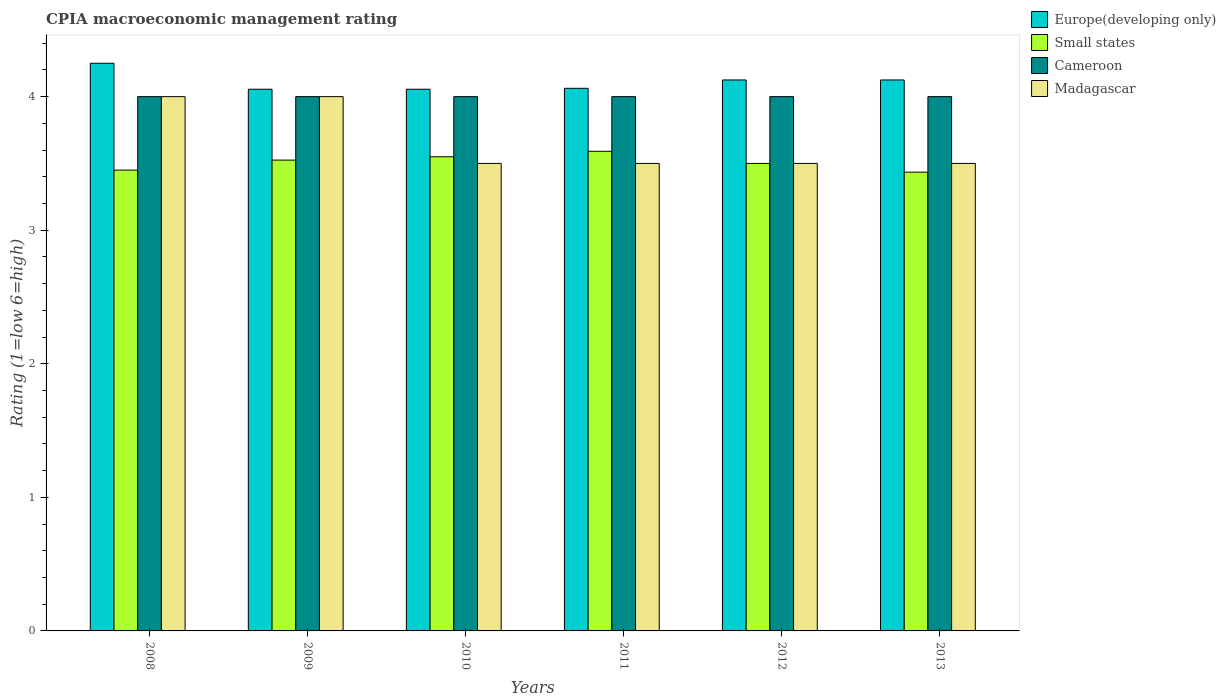How many groups of bars are there?
Ensure brevity in your answer.  6. How many bars are there on the 4th tick from the left?
Give a very brief answer. 4. How many bars are there on the 5th tick from the right?
Your response must be concise. 4. What is the label of the 3rd group of bars from the left?
Ensure brevity in your answer.  2010. In how many cases, is the number of bars for a given year not equal to the number of legend labels?
Your response must be concise. 0. What is the CPIA rating in Europe(developing only) in 2010?
Ensure brevity in your answer.  4.06. Across all years, what is the maximum CPIA rating in Cameroon?
Your answer should be very brief. 4. Across all years, what is the minimum CPIA rating in Madagascar?
Keep it short and to the point. 3.5. In which year was the CPIA rating in Small states maximum?
Your answer should be compact. 2011. What is the total CPIA rating in Cameroon in the graph?
Provide a succinct answer. 24. What is the difference between the CPIA rating in Small states in 2010 and that in 2012?
Offer a very short reply. 0.05. What is the difference between the CPIA rating in Madagascar in 2010 and the CPIA rating in Small states in 2012?
Your response must be concise. 0. What is the average CPIA rating in Europe(developing only) per year?
Offer a very short reply. 4.11. In the year 2013, what is the difference between the CPIA rating in Small states and CPIA rating in Europe(developing only)?
Offer a very short reply. -0.69. What is the ratio of the CPIA rating in Cameroon in 2009 to that in 2010?
Give a very brief answer. 1. Is the difference between the CPIA rating in Small states in 2011 and 2013 greater than the difference between the CPIA rating in Europe(developing only) in 2011 and 2013?
Offer a terse response. Yes. What is the difference between the highest and the second highest CPIA rating in Madagascar?
Provide a short and direct response. 0. What is the difference between the highest and the lowest CPIA rating in Cameroon?
Your response must be concise. 0. What does the 2nd bar from the left in 2009 represents?
Your answer should be very brief. Small states. What does the 4th bar from the right in 2010 represents?
Your answer should be compact. Europe(developing only). Is it the case that in every year, the sum of the CPIA rating in Cameroon and CPIA rating in Europe(developing only) is greater than the CPIA rating in Madagascar?
Provide a succinct answer. Yes. How many bars are there?
Provide a succinct answer. 24. Are the values on the major ticks of Y-axis written in scientific E-notation?
Keep it short and to the point. No. Does the graph contain any zero values?
Your answer should be compact. No. How many legend labels are there?
Provide a succinct answer. 4. How are the legend labels stacked?
Ensure brevity in your answer.  Vertical. What is the title of the graph?
Offer a very short reply. CPIA macroeconomic management rating. What is the label or title of the Y-axis?
Give a very brief answer. Rating (1=low 6=high). What is the Rating (1=low 6=high) in Europe(developing only) in 2008?
Ensure brevity in your answer.  4.25. What is the Rating (1=low 6=high) of Small states in 2008?
Ensure brevity in your answer.  3.45. What is the Rating (1=low 6=high) of Madagascar in 2008?
Keep it short and to the point. 4. What is the Rating (1=low 6=high) in Europe(developing only) in 2009?
Keep it short and to the point. 4.06. What is the Rating (1=low 6=high) of Small states in 2009?
Offer a terse response. 3.52. What is the Rating (1=low 6=high) in Europe(developing only) in 2010?
Your answer should be very brief. 4.06. What is the Rating (1=low 6=high) of Small states in 2010?
Your answer should be very brief. 3.55. What is the Rating (1=low 6=high) of Cameroon in 2010?
Provide a succinct answer. 4. What is the Rating (1=low 6=high) of Europe(developing only) in 2011?
Give a very brief answer. 4.06. What is the Rating (1=low 6=high) in Small states in 2011?
Provide a succinct answer. 3.59. What is the Rating (1=low 6=high) of Europe(developing only) in 2012?
Provide a short and direct response. 4.12. What is the Rating (1=low 6=high) in Small states in 2012?
Your answer should be very brief. 3.5. What is the Rating (1=low 6=high) of Madagascar in 2012?
Offer a terse response. 3.5. What is the Rating (1=low 6=high) of Europe(developing only) in 2013?
Offer a very short reply. 4.12. What is the Rating (1=low 6=high) of Small states in 2013?
Provide a succinct answer. 3.43. What is the Rating (1=low 6=high) in Cameroon in 2013?
Your response must be concise. 4. What is the Rating (1=low 6=high) of Madagascar in 2013?
Make the answer very short. 3.5. Across all years, what is the maximum Rating (1=low 6=high) in Europe(developing only)?
Make the answer very short. 4.25. Across all years, what is the maximum Rating (1=low 6=high) of Small states?
Provide a short and direct response. 3.59. Across all years, what is the maximum Rating (1=low 6=high) of Madagascar?
Offer a terse response. 4. Across all years, what is the minimum Rating (1=low 6=high) in Europe(developing only)?
Provide a short and direct response. 4.06. Across all years, what is the minimum Rating (1=low 6=high) of Small states?
Give a very brief answer. 3.43. What is the total Rating (1=low 6=high) in Europe(developing only) in the graph?
Provide a succinct answer. 24.67. What is the total Rating (1=low 6=high) of Small states in the graph?
Make the answer very short. 21.05. What is the total Rating (1=low 6=high) of Cameroon in the graph?
Offer a terse response. 24. What is the difference between the Rating (1=low 6=high) in Europe(developing only) in 2008 and that in 2009?
Give a very brief answer. 0.19. What is the difference between the Rating (1=low 6=high) in Small states in 2008 and that in 2009?
Offer a very short reply. -0.07. What is the difference between the Rating (1=low 6=high) of Madagascar in 2008 and that in 2009?
Your answer should be compact. 0. What is the difference between the Rating (1=low 6=high) of Europe(developing only) in 2008 and that in 2010?
Offer a terse response. 0.19. What is the difference between the Rating (1=low 6=high) of Cameroon in 2008 and that in 2010?
Your answer should be compact. 0. What is the difference between the Rating (1=low 6=high) of Madagascar in 2008 and that in 2010?
Provide a short and direct response. 0.5. What is the difference between the Rating (1=low 6=high) of Europe(developing only) in 2008 and that in 2011?
Your answer should be compact. 0.19. What is the difference between the Rating (1=low 6=high) in Small states in 2008 and that in 2011?
Keep it short and to the point. -0.14. What is the difference between the Rating (1=low 6=high) in Cameroon in 2008 and that in 2011?
Offer a very short reply. 0. What is the difference between the Rating (1=low 6=high) of Madagascar in 2008 and that in 2011?
Keep it short and to the point. 0.5. What is the difference between the Rating (1=low 6=high) in Cameroon in 2008 and that in 2012?
Your answer should be compact. 0. What is the difference between the Rating (1=low 6=high) in Madagascar in 2008 and that in 2012?
Give a very brief answer. 0.5. What is the difference between the Rating (1=low 6=high) in Europe(developing only) in 2008 and that in 2013?
Provide a short and direct response. 0.12. What is the difference between the Rating (1=low 6=high) in Small states in 2008 and that in 2013?
Ensure brevity in your answer.  0.02. What is the difference between the Rating (1=low 6=high) in Cameroon in 2008 and that in 2013?
Offer a very short reply. 0. What is the difference between the Rating (1=low 6=high) of Europe(developing only) in 2009 and that in 2010?
Give a very brief answer. 0. What is the difference between the Rating (1=low 6=high) of Small states in 2009 and that in 2010?
Offer a terse response. -0.03. What is the difference between the Rating (1=low 6=high) of Cameroon in 2009 and that in 2010?
Give a very brief answer. 0. What is the difference between the Rating (1=low 6=high) in Europe(developing only) in 2009 and that in 2011?
Offer a terse response. -0.01. What is the difference between the Rating (1=low 6=high) of Small states in 2009 and that in 2011?
Provide a short and direct response. -0.07. What is the difference between the Rating (1=low 6=high) of Madagascar in 2009 and that in 2011?
Provide a short and direct response. 0.5. What is the difference between the Rating (1=low 6=high) of Europe(developing only) in 2009 and that in 2012?
Provide a short and direct response. -0.07. What is the difference between the Rating (1=low 6=high) of Small states in 2009 and that in 2012?
Ensure brevity in your answer.  0.03. What is the difference between the Rating (1=low 6=high) of Cameroon in 2009 and that in 2012?
Keep it short and to the point. 0. What is the difference between the Rating (1=low 6=high) of Madagascar in 2009 and that in 2012?
Provide a succinct answer. 0.5. What is the difference between the Rating (1=low 6=high) in Europe(developing only) in 2009 and that in 2013?
Provide a succinct answer. -0.07. What is the difference between the Rating (1=low 6=high) in Small states in 2009 and that in 2013?
Keep it short and to the point. 0.09. What is the difference between the Rating (1=low 6=high) in Cameroon in 2009 and that in 2013?
Your answer should be very brief. 0. What is the difference between the Rating (1=low 6=high) of Europe(developing only) in 2010 and that in 2011?
Provide a short and direct response. -0.01. What is the difference between the Rating (1=low 6=high) in Small states in 2010 and that in 2011?
Provide a short and direct response. -0.04. What is the difference between the Rating (1=low 6=high) in Cameroon in 2010 and that in 2011?
Offer a very short reply. 0. What is the difference between the Rating (1=low 6=high) of Europe(developing only) in 2010 and that in 2012?
Provide a short and direct response. -0.07. What is the difference between the Rating (1=low 6=high) of Small states in 2010 and that in 2012?
Your answer should be compact. 0.05. What is the difference between the Rating (1=low 6=high) of Cameroon in 2010 and that in 2012?
Provide a succinct answer. 0. What is the difference between the Rating (1=low 6=high) of Europe(developing only) in 2010 and that in 2013?
Offer a terse response. -0.07. What is the difference between the Rating (1=low 6=high) of Small states in 2010 and that in 2013?
Keep it short and to the point. 0.12. What is the difference between the Rating (1=low 6=high) in Madagascar in 2010 and that in 2013?
Your answer should be compact. 0. What is the difference between the Rating (1=low 6=high) of Europe(developing only) in 2011 and that in 2012?
Your response must be concise. -0.06. What is the difference between the Rating (1=low 6=high) in Small states in 2011 and that in 2012?
Keep it short and to the point. 0.09. What is the difference between the Rating (1=low 6=high) of Cameroon in 2011 and that in 2012?
Make the answer very short. 0. What is the difference between the Rating (1=low 6=high) in Madagascar in 2011 and that in 2012?
Offer a very short reply. 0. What is the difference between the Rating (1=low 6=high) of Europe(developing only) in 2011 and that in 2013?
Offer a terse response. -0.06. What is the difference between the Rating (1=low 6=high) in Small states in 2011 and that in 2013?
Your answer should be very brief. 0.16. What is the difference between the Rating (1=low 6=high) in Cameroon in 2011 and that in 2013?
Your response must be concise. 0. What is the difference between the Rating (1=low 6=high) of Europe(developing only) in 2012 and that in 2013?
Offer a terse response. 0. What is the difference between the Rating (1=low 6=high) in Small states in 2012 and that in 2013?
Make the answer very short. 0.07. What is the difference between the Rating (1=low 6=high) in Cameroon in 2012 and that in 2013?
Your answer should be compact. 0. What is the difference between the Rating (1=low 6=high) in Europe(developing only) in 2008 and the Rating (1=low 6=high) in Small states in 2009?
Provide a succinct answer. 0.72. What is the difference between the Rating (1=low 6=high) in Europe(developing only) in 2008 and the Rating (1=low 6=high) in Cameroon in 2009?
Your answer should be compact. 0.25. What is the difference between the Rating (1=low 6=high) in Small states in 2008 and the Rating (1=low 6=high) in Cameroon in 2009?
Provide a succinct answer. -0.55. What is the difference between the Rating (1=low 6=high) of Small states in 2008 and the Rating (1=low 6=high) of Madagascar in 2009?
Your answer should be very brief. -0.55. What is the difference between the Rating (1=low 6=high) in Europe(developing only) in 2008 and the Rating (1=low 6=high) in Small states in 2010?
Give a very brief answer. 0.7. What is the difference between the Rating (1=low 6=high) of Small states in 2008 and the Rating (1=low 6=high) of Cameroon in 2010?
Offer a very short reply. -0.55. What is the difference between the Rating (1=low 6=high) in Small states in 2008 and the Rating (1=low 6=high) in Madagascar in 2010?
Ensure brevity in your answer.  -0.05. What is the difference between the Rating (1=low 6=high) in Cameroon in 2008 and the Rating (1=low 6=high) in Madagascar in 2010?
Provide a short and direct response. 0.5. What is the difference between the Rating (1=low 6=high) in Europe(developing only) in 2008 and the Rating (1=low 6=high) in Small states in 2011?
Provide a succinct answer. 0.66. What is the difference between the Rating (1=low 6=high) in Europe(developing only) in 2008 and the Rating (1=low 6=high) in Madagascar in 2011?
Keep it short and to the point. 0.75. What is the difference between the Rating (1=low 6=high) of Small states in 2008 and the Rating (1=low 6=high) of Cameroon in 2011?
Your response must be concise. -0.55. What is the difference between the Rating (1=low 6=high) of Europe(developing only) in 2008 and the Rating (1=low 6=high) of Small states in 2012?
Provide a short and direct response. 0.75. What is the difference between the Rating (1=low 6=high) of Europe(developing only) in 2008 and the Rating (1=low 6=high) of Madagascar in 2012?
Provide a succinct answer. 0.75. What is the difference between the Rating (1=low 6=high) in Small states in 2008 and the Rating (1=low 6=high) in Cameroon in 2012?
Keep it short and to the point. -0.55. What is the difference between the Rating (1=low 6=high) in Small states in 2008 and the Rating (1=low 6=high) in Madagascar in 2012?
Provide a succinct answer. -0.05. What is the difference between the Rating (1=low 6=high) of Cameroon in 2008 and the Rating (1=low 6=high) of Madagascar in 2012?
Give a very brief answer. 0.5. What is the difference between the Rating (1=low 6=high) in Europe(developing only) in 2008 and the Rating (1=low 6=high) in Small states in 2013?
Your response must be concise. 0.82. What is the difference between the Rating (1=low 6=high) of Europe(developing only) in 2008 and the Rating (1=low 6=high) of Cameroon in 2013?
Offer a terse response. 0.25. What is the difference between the Rating (1=low 6=high) in Europe(developing only) in 2008 and the Rating (1=low 6=high) in Madagascar in 2013?
Your response must be concise. 0.75. What is the difference between the Rating (1=low 6=high) in Small states in 2008 and the Rating (1=low 6=high) in Cameroon in 2013?
Ensure brevity in your answer.  -0.55. What is the difference between the Rating (1=low 6=high) of Small states in 2008 and the Rating (1=low 6=high) of Madagascar in 2013?
Keep it short and to the point. -0.05. What is the difference between the Rating (1=low 6=high) of Europe(developing only) in 2009 and the Rating (1=low 6=high) of Small states in 2010?
Provide a short and direct response. 0.51. What is the difference between the Rating (1=low 6=high) in Europe(developing only) in 2009 and the Rating (1=low 6=high) in Cameroon in 2010?
Provide a short and direct response. 0.06. What is the difference between the Rating (1=low 6=high) in Europe(developing only) in 2009 and the Rating (1=low 6=high) in Madagascar in 2010?
Your answer should be very brief. 0.56. What is the difference between the Rating (1=low 6=high) of Small states in 2009 and the Rating (1=low 6=high) of Cameroon in 2010?
Keep it short and to the point. -0.47. What is the difference between the Rating (1=low 6=high) of Small states in 2009 and the Rating (1=low 6=high) of Madagascar in 2010?
Your answer should be very brief. 0.03. What is the difference between the Rating (1=low 6=high) in Europe(developing only) in 2009 and the Rating (1=low 6=high) in Small states in 2011?
Give a very brief answer. 0.46. What is the difference between the Rating (1=low 6=high) in Europe(developing only) in 2009 and the Rating (1=low 6=high) in Cameroon in 2011?
Provide a succinct answer. 0.06. What is the difference between the Rating (1=low 6=high) in Europe(developing only) in 2009 and the Rating (1=low 6=high) in Madagascar in 2011?
Offer a very short reply. 0.56. What is the difference between the Rating (1=low 6=high) in Small states in 2009 and the Rating (1=low 6=high) in Cameroon in 2011?
Your response must be concise. -0.47. What is the difference between the Rating (1=low 6=high) of Small states in 2009 and the Rating (1=low 6=high) of Madagascar in 2011?
Give a very brief answer. 0.03. What is the difference between the Rating (1=low 6=high) of Cameroon in 2009 and the Rating (1=low 6=high) of Madagascar in 2011?
Keep it short and to the point. 0.5. What is the difference between the Rating (1=low 6=high) of Europe(developing only) in 2009 and the Rating (1=low 6=high) of Small states in 2012?
Your answer should be compact. 0.56. What is the difference between the Rating (1=low 6=high) of Europe(developing only) in 2009 and the Rating (1=low 6=high) of Cameroon in 2012?
Provide a succinct answer. 0.06. What is the difference between the Rating (1=low 6=high) of Europe(developing only) in 2009 and the Rating (1=low 6=high) of Madagascar in 2012?
Offer a very short reply. 0.56. What is the difference between the Rating (1=low 6=high) of Small states in 2009 and the Rating (1=low 6=high) of Cameroon in 2012?
Your response must be concise. -0.47. What is the difference between the Rating (1=low 6=high) of Small states in 2009 and the Rating (1=low 6=high) of Madagascar in 2012?
Your answer should be compact. 0.03. What is the difference between the Rating (1=low 6=high) of Europe(developing only) in 2009 and the Rating (1=low 6=high) of Small states in 2013?
Offer a terse response. 0.62. What is the difference between the Rating (1=low 6=high) in Europe(developing only) in 2009 and the Rating (1=low 6=high) in Cameroon in 2013?
Your answer should be very brief. 0.06. What is the difference between the Rating (1=low 6=high) in Europe(developing only) in 2009 and the Rating (1=low 6=high) in Madagascar in 2013?
Offer a very short reply. 0.56. What is the difference between the Rating (1=low 6=high) of Small states in 2009 and the Rating (1=low 6=high) of Cameroon in 2013?
Your response must be concise. -0.47. What is the difference between the Rating (1=low 6=high) in Small states in 2009 and the Rating (1=low 6=high) in Madagascar in 2013?
Ensure brevity in your answer.  0.03. What is the difference between the Rating (1=low 6=high) in Cameroon in 2009 and the Rating (1=low 6=high) in Madagascar in 2013?
Give a very brief answer. 0.5. What is the difference between the Rating (1=low 6=high) of Europe(developing only) in 2010 and the Rating (1=low 6=high) of Small states in 2011?
Your answer should be compact. 0.46. What is the difference between the Rating (1=low 6=high) of Europe(developing only) in 2010 and the Rating (1=low 6=high) of Cameroon in 2011?
Give a very brief answer. 0.06. What is the difference between the Rating (1=low 6=high) in Europe(developing only) in 2010 and the Rating (1=low 6=high) in Madagascar in 2011?
Offer a terse response. 0.56. What is the difference between the Rating (1=low 6=high) in Small states in 2010 and the Rating (1=low 6=high) in Cameroon in 2011?
Offer a terse response. -0.45. What is the difference between the Rating (1=low 6=high) of Small states in 2010 and the Rating (1=low 6=high) of Madagascar in 2011?
Give a very brief answer. 0.05. What is the difference between the Rating (1=low 6=high) of Cameroon in 2010 and the Rating (1=low 6=high) of Madagascar in 2011?
Offer a very short reply. 0.5. What is the difference between the Rating (1=low 6=high) in Europe(developing only) in 2010 and the Rating (1=low 6=high) in Small states in 2012?
Your response must be concise. 0.56. What is the difference between the Rating (1=low 6=high) of Europe(developing only) in 2010 and the Rating (1=low 6=high) of Cameroon in 2012?
Ensure brevity in your answer.  0.06. What is the difference between the Rating (1=low 6=high) of Europe(developing only) in 2010 and the Rating (1=low 6=high) of Madagascar in 2012?
Your answer should be very brief. 0.56. What is the difference between the Rating (1=low 6=high) in Small states in 2010 and the Rating (1=low 6=high) in Cameroon in 2012?
Keep it short and to the point. -0.45. What is the difference between the Rating (1=low 6=high) in Small states in 2010 and the Rating (1=low 6=high) in Madagascar in 2012?
Your answer should be very brief. 0.05. What is the difference between the Rating (1=low 6=high) of Europe(developing only) in 2010 and the Rating (1=low 6=high) of Small states in 2013?
Your answer should be compact. 0.62. What is the difference between the Rating (1=low 6=high) in Europe(developing only) in 2010 and the Rating (1=low 6=high) in Cameroon in 2013?
Offer a terse response. 0.06. What is the difference between the Rating (1=low 6=high) in Europe(developing only) in 2010 and the Rating (1=low 6=high) in Madagascar in 2013?
Your response must be concise. 0.56. What is the difference between the Rating (1=low 6=high) in Small states in 2010 and the Rating (1=low 6=high) in Cameroon in 2013?
Offer a terse response. -0.45. What is the difference between the Rating (1=low 6=high) in Europe(developing only) in 2011 and the Rating (1=low 6=high) in Small states in 2012?
Give a very brief answer. 0.56. What is the difference between the Rating (1=low 6=high) in Europe(developing only) in 2011 and the Rating (1=low 6=high) in Cameroon in 2012?
Offer a very short reply. 0.06. What is the difference between the Rating (1=low 6=high) in Europe(developing only) in 2011 and the Rating (1=low 6=high) in Madagascar in 2012?
Make the answer very short. 0.56. What is the difference between the Rating (1=low 6=high) of Small states in 2011 and the Rating (1=low 6=high) of Cameroon in 2012?
Provide a succinct answer. -0.41. What is the difference between the Rating (1=low 6=high) in Small states in 2011 and the Rating (1=low 6=high) in Madagascar in 2012?
Provide a succinct answer. 0.09. What is the difference between the Rating (1=low 6=high) of Cameroon in 2011 and the Rating (1=low 6=high) of Madagascar in 2012?
Provide a succinct answer. 0.5. What is the difference between the Rating (1=low 6=high) in Europe(developing only) in 2011 and the Rating (1=low 6=high) in Small states in 2013?
Keep it short and to the point. 0.63. What is the difference between the Rating (1=low 6=high) in Europe(developing only) in 2011 and the Rating (1=low 6=high) in Cameroon in 2013?
Make the answer very short. 0.06. What is the difference between the Rating (1=low 6=high) of Europe(developing only) in 2011 and the Rating (1=low 6=high) of Madagascar in 2013?
Ensure brevity in your answer.  0.56. What is the difference between the Rating (1=low 6=high) of Small states in 2011 and the Rating (1=low 6=high) of Cameroon in 2013?
Provide a succinct answer. -0.41. What is the difference between the Rating (1=low 6=high) in Small states in 2011 and the Rating (1=low 6=high) in Madagascar in 2013?
Give a very brief answer. 0.09. What is the difference between the Rating (1=low 6=high) of Europe(developing only) in 2012 and the Rating (1=low 6=high) of Small states in 2013?
Your answer should be very brief. 0.69. What is the difference between the Rating (1=low 6=high) of Europe(developing only) in 2012 and the Rating (1=low 6=high) of Madagascar in 2013?
Ensure brevity in your answer.  0.62. What is the difference between the Rating (1=low 6=high) in Small states in 2012 and the Rating (1=low 6=high) in Cameroon in 2013?
Your response must be concise. -0.5. What is the average Rating (1=low 6=high) of Europe(developing only) per year?
Keep it short and to the point. 4.11. What is the average Rating (1=low 6=high) in Small states per year?
Make the answer very short. 3.51. What is the average Rating (1=low 6=high) in Madagascar per year?
Keep it short and to the point. 3.67. In the year 2008, what is the difference between the Rating (1=low 6=high) in Europe(developing only) and Rating (1=low 6=high) in Cameroon?
Ensure brevity in your answer.  0.25. In the year 2008, what is the difference between the Rating (1=low 6=high) in Europe(developing only) and Rating (1=low 6=high) in Madagascar?
Make the answer very short. 0.25. In the year 2008, what is the difference between the Rating (1=low 6=high) in Small states and Rating (1=low 6=high) in Cameroon?
Offer a terse response. -0.55. In the year 2008, what is the difference between the Rating (1=low 6=high) of Small states and Rating (1=low 6=high) of Madagascar?
Your answer should be very brief. -0.55. In the year 2008, what is the difference between the Rating (1=low 6=high) in Cameroon and Rating (1=low 6=high) in Madagascar?
Offer a terse response. 0. In the year 2009, what is the difference between the Rating (1=low 6=high) in Europe(developing only) and Rating (1=low 6=high) in Small states?
Your response must be concise. 0.53. In the year 2009, what is the difference between the Rating (1=low 6=high) of Europe(developing only) and Rating (1=low 6=high) of Cameroon?
Provide a short and direct response. 0.06. In the year 2009, what is the difference between the Rating (1=low 6=high) in Europe(developing only) and Rating (1=low 6=high) in Madagascar?
Provide a succinct answer. 0.06. In the year 2009, what is the difference between the Rating (1=low 6=high) of Small states and Rating (1=low 6=high) of Cameroon?
Give a very brief answer. -0.47. In the year 2009, what is the difference between the Rating (1=low 6=high) in Small states and Rating (1=low 6=high) in Madagascar?
Your response must be concise. -0.47. In the year 2009, what is the difference between the Rating (1=low 6=high) in Cameroon and Rating (1=low 6=high) in Madagascar?
Give a very brief answer. 0. In the year 2010, what is the difference between the Rating (1=low 6=high) of Europe(developing only) and Rating (1=low 6=high) of Small states?
Ensure brevity in your answer.  0.51. In the year 2010, what is the difference between the Rating (1=low 6=high) of Europe(developing only) and Rating (1=low 6=high) of Cameroon?
Offer a very short reply. 0.06. In the year 2010, what is the difference between the Rating (1=low 6=high) of Europe(developing only) and Rating (1=low 6=high) of Madagascar?
Provide a short and direct response. 0.56. In the year 2010, what is the difference between the Rating (1=low 6=high) in Small states and Rating (1=low 6=high) in Cameroon?
Offer a very short reply. -0.45. In the year 2010, what is the difference between the Rating (1=low 6=high) in Small states and Rating (1=low 6=high) in Madagascar?
Offer a terse response. 0.05. In the year 2011, what is the difference between the Rating (1=low 6=high) in Europe(developing only) and Rating (1=low 6=high) in Small states?
Keep it short and to the point. 0.47. In the year 2011, what is the difference between the Rating (1=low 6=high) in Europe(developing only) and Rating (1=low 6=high) in Cameroon?
Ensure brevity in your answer.  0.06. In the year 2011, what is the difference between the Rating (1=low 6=high) of Europe(developing only) and Rating (1=low 6=high) of Madagascar?
Provide a succinct answer. 0.56. In the year 2011, what is the difference between the Rating (1=low 6=high) of Small states and Rating (1=low 6=high) of Cameroon?
Your answer should be compact. -0.41. In the year 2011, what is the difference between the Rating (1=low 6=high) in Small states and Rating (1=low 6=high) in Madagascar?
Provide a short and direct response. 0.09. In the year 2012, what is the difference between the Rating (1=low 6=high) of Europe(developing only) and Rating (1=low 6=high) of Small states?
Ensure brevity in your answer.  0.62. In the year 2012, what is the difference between the Rating (1=low 6=high) of Europe(developing only) and Rating (1=low 6=high) of Cameroon?
Ensure brevity in your answer.  0.12. In the year 2012, what is the difference between the Rating (1=low 6=high) in Europe(developing only) and Rating (1=low 6=high) in Madagascar?
Offer a terse response. 0.62. In the year 2012, what is the difference between the Rating (1=low 6=high) in Small states and Rating (1=low 6=high) in Cameroon?
Make the answer very short. -0.5. In the year 2013, what is the difference between the Rating (1=low 6=high) in Europe(developing only) and Rating (1=low 6=high) in Small states?
Provide a succinct answer. 0.69. In the year 2013, what is the difference between the Rating (1=low 6=high) of Europe(developing only) and Rating (1=low 6=high) of Cameroon?
Provide a succinct answer. 0.12. In the year 2013, what is the difference between the Rating (1=low 6=high) of Europe(developing only) and Rating (1=low 6=high) of Madagascar?
Your answer should be compact. 0.62. In the year 2013, what is the difference between the Rating (1=low 6=high) of Small states and Rating (1=low 6=high) of Cameroon?
Offer a terse response. -0.57. In the year 2013, what is the difference between the Rating (1=low 6=high) of Small states and Rating (1=low 6=high) of Madagascar?
Make the answer very short. -0.07. What is the ratio of the Rating (1=low 6=high) of Europe(developing only) in 2008 to that in 2009?
Ensure brevity in your answer.  1.05. What is the ratio of the Rating (1=low 6=high) in Small states in 2008 to that in 2009?
Offer a very short reply. 0.98. What is the ratio of the Rating (1=low 6=high) of Madagascar in 2008 to that in 2009?
Ensure brevity in your answer.  1. What is the ratio of the Rating (1=low 6=high) of Europe(developing only) in 2008 to that in 2010?
Offer a very short reply. 1.05. What is the ratio of the Rating (1=low 6=high) in Small states in 2008 to that in 2010?
Provide a short and direct response. 0.97. What is the ratio of the Rating (1=low 6=high) in Cameroon in 2008 to that in 2010?
Keep it short and to the point. 1. What is the ratio of the Rating (1=low 6=high) of Europe(developing only) in 2008 to that in 2011?
Give a very brief answer. 1.05. What is the ratio of the Rating (1=low 6=high) in Small states in 2008 to that in 2011?
Provide a succinct answer. 0.96. What is the ratio of the Rating (1=low 6=high) in Madagascar in 2008 to that in 2011?
Offer a very short reply. 1.14. What is the ratio of the Rating (1=low 6=high) of Europe(developing only) in 2008 to that in 2012?
Keep it short and to the point. 1.03. What is the ratio of the Rating (1=low 6=high) in Small states in 2008 to that in 2012?
Provide a succinct answer. 0.99. What is the ratio of the Rating (1=low 6=high) of Cameroon in 2008 to that in 2012?
Provide a succinct answer. 1. What is the ratio of the Rating (1=low 6=high) in Madagascar in 2008 to that in 2012?
Keep it short and to the point. 1.14. What is the ratio of the Rating (1=low 6=high) in Europe(developing only) in 2008 to that in 2013?
Give a very brief answer. 1.03. What is the ratio of the Rating (1=low 6=high) in Cameroon in 2008 to that in 2013?
Your answer should be compact. 1. What is the ratio of the Rating (1=low 6=high) of Madagascar in 2008 to that in 2013?
Your response must be concise. 1.14. What is the ratio of the Rating (1=low 6=high) in Small states in 2009 to that in 2010?
Provide a short and direct response. 0.99. What is the ratio of the Rating (1=low 6=high) in Cameroon in 2009 to that in 2010?
Keep it short and to the point. 1. What is the ratio of the Rating (1=low 6=high) of Small states in 2009 to that in 2011?
Your answer should be compact. 0.98. What is the ratio of the Rating (1=low 6=high) in Madagascar in 2009 to that in 2011?
Keep it short and to the point. 1.14. What is the ratio of the Rating (1=low 6=high) of Europe(developing only) in 2009 to that in 2012?
Ensure brevity in your answer.  0.98. What is the ratio of the Rating (1=low 6=high) in Small states in 2009 to that in 2012?
Your response must be concise. 1.01. What is the ratio of the Rating (1=low 6=high) in Cameroon in 2009 to that in 2012?
Provide a succinct answer. 1. What is the ratio of the Rating (1=low 6=high) of Europe(developing only) in 2009 to that in 2013?
Keep it short and to the point. 0.98. What is the ratio of the Rating (1=low 6=high) in Small states in 2009 to that in 2013?
Offer a terse response. 1.03. What is the ratio of the Rating (1=low 6=high) in Cameroon in 2009 to that in 2013?
Keep it short and to the point. 1. What is the ratio of the Rating (1=low 6=high) of Madagascar in 2009 to that in 2013?
Offer a terse response. 1.14. What is the ratio of the Rating (1=low 6=high) of Europe(developing only) in 2010 to that in 2011?
Ensure brevity in your answer.  1. What is the ratio of the Rating (1=low 6=high) in Madagascar in 2010 to that in 2011?
Ensure brevity in your answer.  1. What is the ratio of the Rating (1=low 6=high) of Europe(developing only) in 2010 to that in 2012?
Your response must be concise. 0.98. What is the ratio of the Rating (1=low 6=high) in Small states in 2010 to that in 2012?
Ensure brevity in your answer.  1.01. What is the ratio of the Rating (1=low 6=high) in Cameroon in 2010 to that in 2012?
Provide a succinct answer. 1. What is the ratio of the Rating (1=low 6=high) of Europe(developing only) in 2010 to that in 2013?
Your response must be concise. 0.98. What is the ratio of the Rating (1=low 6=high) in Small states in 2010 to that in 2013?
Provide a succinct answer. 1.03. What is the ratio of the Rating (1=low 6=high) in Cameroon in 2011 to that in 2012?
Make the answer very short. 1. What is the ratio of the Rating (1=low 6=high) of Small states in 2011 to that in 2013?
Offer a very short reply. 1.05. What is the ratio of the Rating (1=low 6=high) of Cameroon in 2011 to that in 2013?
Give a very brief answer. 1. What is the ratio of the Rating (1=low 6=high) in Small states in 2012 to that in 2013?
Your answer should be compact. 1.02. What is the difference between the highest and the second highest Rating (1=low 6=high) in Small states?
Ensure brevity in your answer.  0.04. What is the difference between the highest and the second highest Rating (1=low 6=high) of Cameroon?
Your answer should be very brief. 0. What is the difference between the highest and the second highest Rating (1=low 6=high) of Madagascar?
Make the answer very short. 0. What is the difference between the highest and the lowest Rating (1=low 6=high) of Europe(developing only)?
Your answer should be compact. 0.19. What is the difference between the highest and the lowest Rating (1=low 6=high) of Small states?
Make the answer very short. 0.16. What is the difference between the highest and the lowest Rating (1=low 6=high) in Madagascar?
Make the answer very short. 0.5. 